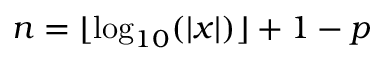Convert formula to latex. <formula><loc_0><loc_0><loc_500><loc_500>n = \lfloor \log _ { 1 0 } ( | x | ) \rfloor + 1 - p</formula> 